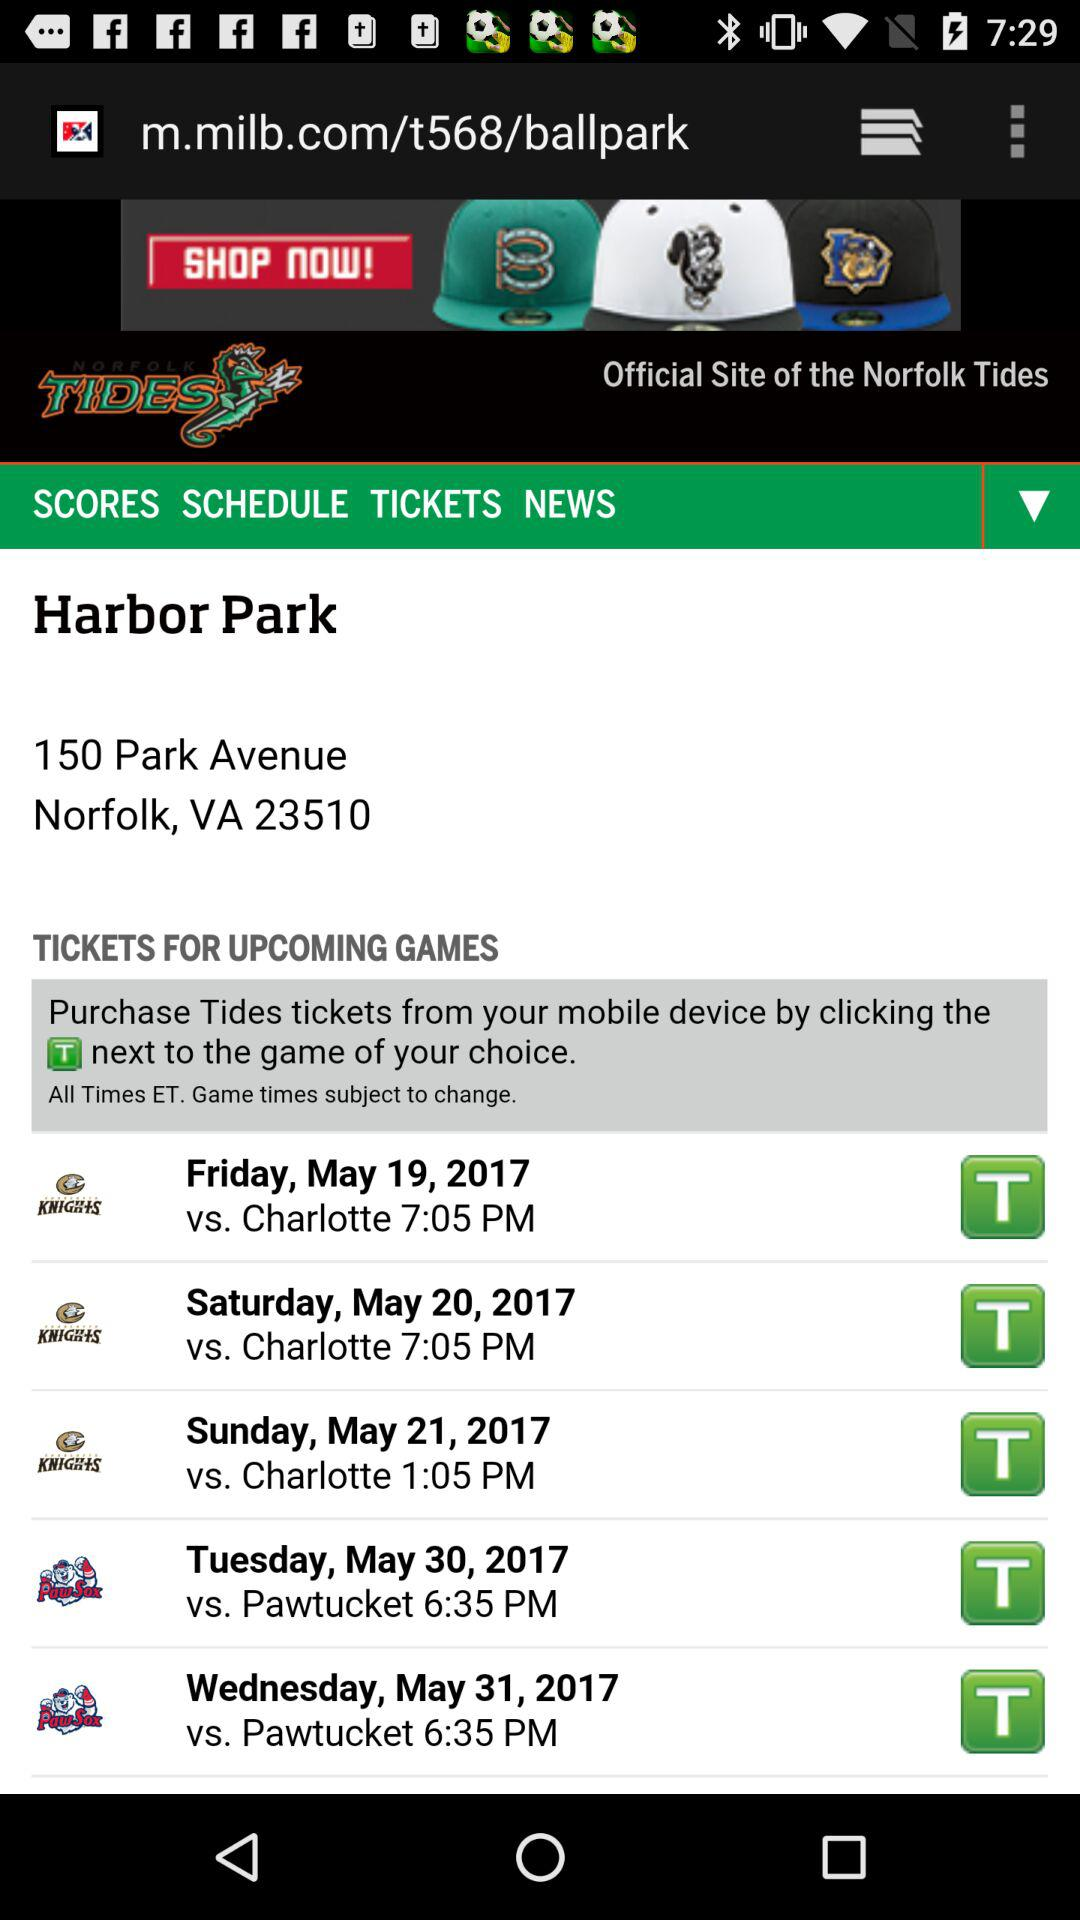What team will play against the Knights on the 21st of May? The team is "Charlotte". 